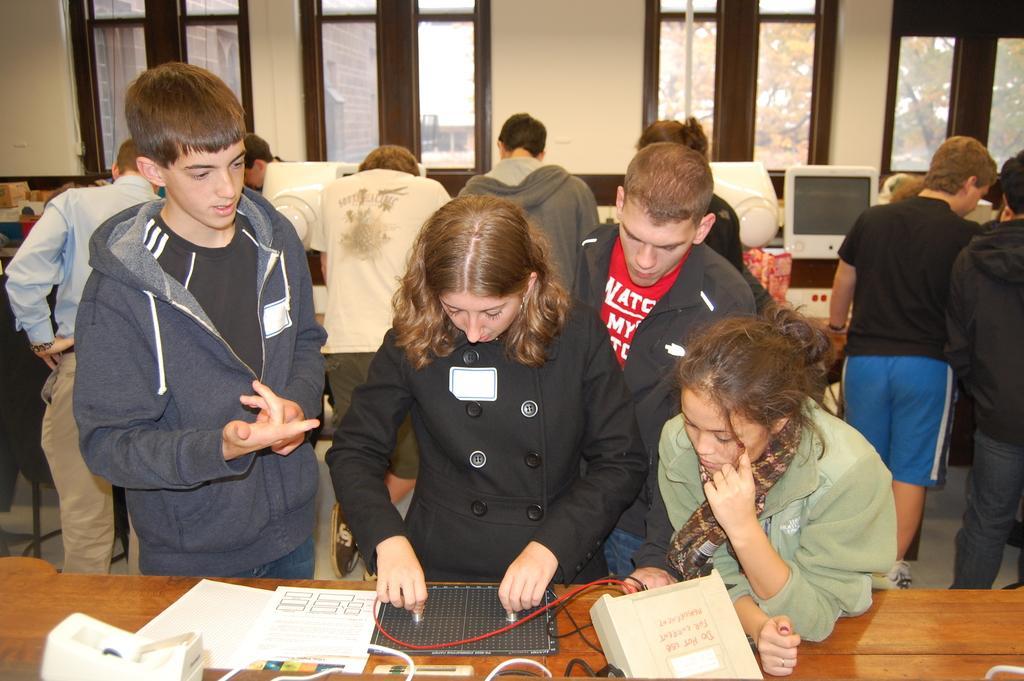Please provide a concise description of this image. In this image there are people, windows, tablet, monitor and objects. Through the windows I can see a building and trees.   